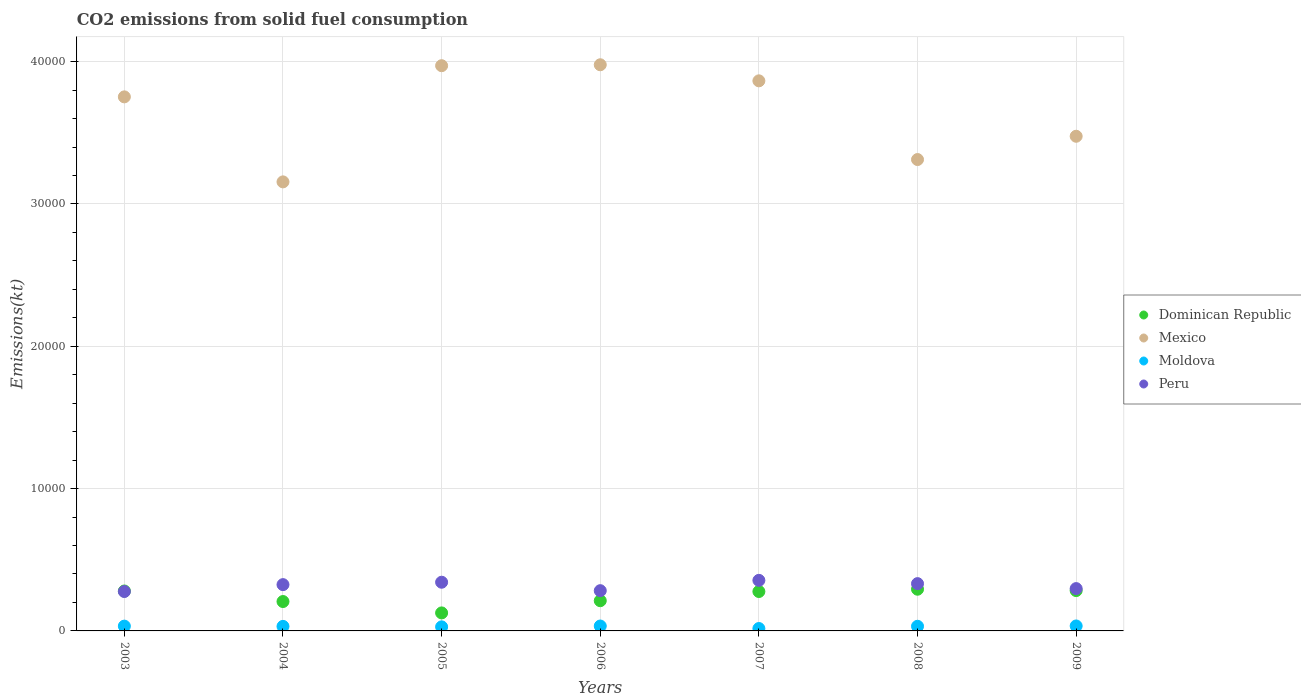What is the amount of CO2 emitted in Mexico in 2005?
Give a very brief answer. 3.97e+04. Across all years, what is the maximum amount of CO2 emitted in Moldova?
Your answer should be compact. 348.37. Across all years, what is the minimum amount of CO2 emitted in Moldova?
Offer a terse response. 168.68. What is the total amount of CO2 emitted in Peru in the graph?
Your response must be concise. 2.21e+04. What is the difference between the amount of CO2 emitted in Peru in 2003 and that in 2004?
Make the answer very short. -484.04. What is the difference between the amount of CO2 emitted in Dominican Republic in 2006 and the amount of CO2 emitted in Peru in 2009?
Your response must be concise. -850.74. What is the average amount of CO2 emitted in Dominican Republic per year?
Offer a very short reply. 2398.74. In the year 2003, what is the difference between the amount of CO2 emitted in Dominican Republic and amount of CO2 emitted in Moldova?
Make the answer very short. 2467.89. In how many years, is the amount of CO2 emitted in Mexico greater than 38000 kt?
Your answer should be compact. 3. What is the ratio of the amount of CO2 emitted in Peru in 2003 to that in 2007?
Give a very brief answer. 0.78. What is the difference between the highest and the second highest amount of CO2 emitted in Mexico?
Provide a succinct answer. 66.01. What is the difference between the highest and the lowest amount of CO2 emitted in Mexico?
Provide a short and direct response. 8228.75. In how many years, is the amount of CO2 emitted in Moldova greater than the average amount of CO2 emitted in Moldova taken over all years?
Offer a terse response. 5. Is the sum of the amount of CO2 emitted in Dominican Republic in 2007 and 2008 greater than the maximum amount of CO2 emitted in Moldova across all years?
Ensure brevity in your answer.  Yes. Is it the case that in every year, the sum of the amount of CO2 emitted in Moldova and amount of CO2 emitted in Mexico  is greater than the sum of amount of CO2 emitted in Peru and amount of CO2 emitted in Dominican Republic?
Provide a short and direct response. Yes. Is it the case that in every year, the sum of the amount of CO2 emitted in Moldova and amount of CO2 emitted in Dominican Republic  is greater than the amount of CO2 emitted in Peru?
Provide a succinct answer. No. Does the amount of CO2 emitted in Peru monotonically increase over the years?
Make the answer very short. No. Is the amount of CO2 emitted in Peru strictly greater than the amount of CO2 emitted in Dominican Republic over the years?
Make the answer very short. No. How many dotlines are there?
Offer a terse response. 4. How many years are there in the graph?
Your answer should be compact. 7. Are the values on the major ticks of Y-axis written in scientific E-notation?
Give a very brief answer. No. Does the graph contain any zero values?
Provide a succinct answer. No. Does the graph contain grids?
Your answer should be compact. Yes. How many legend labels are there?
Keep it short and to the point. 4. How are the legend labels stacked?
Your response must be concise. Vertical. What is the title of the graph?
Make the answer very short. CO2 emissions from solid fuel consumption. Does "Comoros" appear as one of the legend labels in the graph?
Your answer should be very brief. No. What is the label or title of the Y-axis?
Your answer should be compact. Emissions(kt). What is the Emissions(kt) in Dominican Republic in 2003?
Give a very brief answer. 2805.26. What is the Emissions(kt) of Mexico in 2003?
Give a very brief answer. 3.75e+04. What is the Emissions(kt) of Moldova in 2003?
Offer a terse response. 337.36. What is the Emissions(kt) of Peru in 2003?
Your response must be concise. 2768.59. What is the Emissions(kt) of Dominican Republic in 2004?
Give a very brief answer. 2064.52. What is the Emissions(kt) of Mexico in 2004?
Offer a very short reply. 3.16e+04. What is the Emissions(kt) of Moldova in 2004?
Make the answer very short. 319.03. What is the Emissions(kt) in Peru in 2004?
Offer a terse response. 3252.63. What is the Emissions(kt) in Dominican Republic in 2005?
Your response must be concise. 1265.12. What is the Emissions(kt) of Mexico in 2005?
Provide a succinct answer. 3.97e+04. What is the Emissions(kt) of Moldova in 2005?
Make the answer very short. 286.03. What is the Emissions(kt) of Peru in 2005?
Your response must be concise. 3421.31. What is the Emissions(kt) in Dominican Republic in 2006?
Keep it short and to the point. 2123.19. What is the Emissions(kt) in Mexico in 2006?
Offer a terse response. 3.98e+04. What is the Emissions(kt) in Moldova in 2006?
Ensure brevity in your answer.  344.7. What is the Emissions(kt) of Peru in 2006?
Give a very brief answer. 2827.26. What is the Emissions(kt) in Dominican Republic in 2007?
Make the answer very short. 2768.59. What is the Emissions(kt) of Mexico in 2007?
Give a very brief answer. 3.87e+04. What is the Emissions(kt) in Moldova in 2007?
Make the answer very short. 168.68. What is the Emissions(kt) in Peru in 2007?
Give a very brief answer. 3553.32. What is the Emissions(kt) in Dominican Republic in 2008?
Keep it short and to the point. 2929.93. What is the Emissions(kt) in Mexico in 2008?
Offer a very short reply. 3.31e+04. What is the Emissions(kt) in Moldova in 2008?
Offer a very short reply. 326.36. What is the Emissions(kt) in Peru in 2008?
Offer a very short reply. 3322.3. What is the Emissions(kt) in Dominican Republic in 2009?
Ensure brevity in your answer.  2834.59. What is the Emissions(kt) of Mexico in 2009?
Provide a short and direct response. 3.48e+04. What is the Emissions(kt) in Moldova in 2009?
Provide a short and direct response. 348.37. What is the Emissions(kt) of Peru in 2009?
Provide a succinct answer. 2973.94. Across all years, what is the maximum Emissions(kt) in Dominican Republic?
Keep it short and to the point. 2929.93. Across all years, what is the maximum Emissions(kt) of Mexico?
Make the answer very short. 3.98e+04. Across all years, what is the maximum Emissions(kt) in Moldova?
Make the answer very short. 348.37. Across all years, what is the maximum Emissions(kt) in Peru?
Keep it short and to the point. 3553.32. Across all years, what is the minimum Emissions(kt) in Dominican Republic?
Make the answer very short. 1265.12. Across all years, what is the minimum Emissions(kt) of Mexico?
Make the answer very short. 3.16e+04. Across all years, what is the minimum Emissions(kt) in Moldova?
Your answer should be very brief. 168.68. Across all years, what is the minimum Emissions(kt) of Peru?
Offer a terse response. 2768.59. What is the total Emissions(kt) of Dominican Republic in the graph?
Offer a terse response. 1.68e+04. What is the total Emissions(kt) of Mexico in the graph?
Your answer should be very brief. 2.55e+05. What is the total Emissions(kt) of Moldova in the graph?
Your response must be concise. 2130.53. What is the total Emissions(kt) in Peru in the graph?
Provide a short and direct response. 2.21e+04. What is the difference between the Emissions(kt) of Dominican Republic in 2003 and that in 2004?
Give a very brief answer. 740.73. What is the difference between the Emissions(kt) of Mexico in 2003 and that in 2004?
Provide a short and direct response. 5973.54. What is the difference between the Emissions(kt) of Moldova in 2003 and that in 2004?
Give a very brief answer. 18.34. What is the difference between the Emissions(kt) in Peru in 2003 and that in 2004?
Your response must be concise. -484.04. What is the difference between the Emissions(kt) of Dominican Republic in 2003 and that in 2005?
Provide a succinct answer. 1540.14. What is the difference between the Emissions(kt) in Mexico in 2003 and that in 2005?
Offer a very short reply. -2189.2. What is the difference between the Emissions(kt) of Moldova in 2003 and that in 2005?
Your answer should be compact. 51.34. What is the difference between the Emissions(kt) of Peru in 2003 and that in 2005?
Your response must be concise. -652.73. What is the difference between the Emissions(kt) in Dominican Republic in 2003 and that in 2006?
Ensure brevity in your answer.  682.06. What is the difference between the Emissions(kt) in Mexico in 2003 and that in 2006?
Your answer should be compact. -2255.2. What is the difference between the Emissions(kt) of Moldova in 2003 and that in 2006?
Provide a succinct answer. -7.33. What is the difference between the Emissions(kt) in Peru in 2003 and that in 2006?
Keep it short and to the point. -58.67. What is the difference between the Emissions(kt) in Dominican Republic in 2003 and that in 2007?
Keep it short and to the point. 36.67. What is the difference between the Emissions(kt) in Mexico in 2003 and that in 2007?
Your answer should be compact. -1125.77. What is the difference between the Emissions(kt) of Moldova in 2003 and that in 2007?
Keep it short and to the point. 168.68. What is the difference between the Emissions(kt) of Peru in 2003 and that in 2007?
Offer a terse response. -784.74. What is the difference between the Emissions(kt) in Dominican Republic in 2003 and that in 2008?
Offer a terse response. -124.68. What is the difference between the Emissions(kt) in Mexico in 2003 and that in 2008?
Offer a terse response. 4404.07. What is the difference between the Emissions(kt) of Moldova in 2003 and that in 2008?
Keep it short and to the point. 11. What is the difference between the Emissions(kt) of Peru in 2003 and that in 2008?
Provide a short and direct response. -553.72. What is the difference between the Emissions(kt) of Dominican Republic in 2003 and that in 2009?
Your answer should be compact. -29.34. What is the difference between the Emissions(kt) of Mexico in 2003 and that in 2009?
Ensure brevity in your answer.  2768.59. What is the difference between the Emissions(kt) of Moldova in 2003 and that in 2009?
Provide a short and direct response. -11. What is the difference between the Emissions(kt) of Peru in 2003 and that in 2009?
Keep it short and to the point. -205.35. What is the difference between the Emissions(kt) in Dominican Republic in 2004 and that in 2005?
Your answer should be compact. 799.41. What is the difference between the Emissions(kt) of Mexico in 2004 and that in 2005?
Provide a short and direct response. -8162.74. What is the difference between the Emissions(kt) in Moldova in 2004 and that in 2005?
Your answer should be compact. 33. What is the difference between the Emissions(kt) of Peru in 2004 and that in 2005?
Your answer should be compact. -168.68. What is the difference between the Emissions(kt) in Dominican Republic in 2004 and that in 2006?
Offer a very short reply. -58.67. What is the difference between the Emissions(kt) of Mexico in 2004 and that in 2006?
Provide a succinct answer. -8228.75. What is the difference between the Emissions(kt) in Moldova in 2004 and that in 2006?
Ensure brevity in your answer.  -25.67. What is the difference between the Emissions(kt) in Peru in 2004 and that in 2006?
Make the answer very short. 425.37. What is the difference between the Emissions(kt) of Dominican Republic in 2004 and that in 2007?
Make the answer very short. -704.06. What is the difference between the Emissions(kt) of Mexico in 2004 and that in 2007?
Ensure brevity in your answer.  -7099.31. What is the difference between the Emissions(kt) of Moldova in 2004 and that in 2007?
Your answer should be compact. 150.35. What is the difference between the Emissions(kt) of Peru in 2004 and that in 2007?
Provide a succinct answer. -300.69. What is the difference between the Emissions(kt) of Dominican Republic in 2004 and that in 2008?
Your answer should be compact. -865.41. What is the difference between the Emissions(kt) in Mexico in 2004 and that in 2008?
Your answer should be compact. -1569.48. What is the difference between the Emissions(kt) of Moldova in 2004 and that in 2008?
Ensure brevity in your answer.  -7.33. What is the difference between the Emissions(kt) of Peru in 2004 and that in 2008?
Keep it short and to the point. -69.67. What is the difference between the Emissions(kt) in Dominican Republic in 2004 and that in 2009?
Make the answer very short. -770.07. What is the difference between the Emissions(kt) in Mexico in 2004 and that in 2009?
Your answer should be very brief. -3204.96. What is the difference between the Emissions(kt) of Moldova in 2004 and that in 2009?
Provide a succinct answer. -29.34. What is the difference between the Emissions(kt) of Peru in 2004 and that in 2009?
Your response must be concise. 278.69. What is the difference between the Emissions(kt) of Dominican Republic in 2005 and that in 2006?
Provide a succinct answer. -858.08. What is the difference between the Emissions(kt) of Mexico in 2005 and that in 2006?
Keep it short and to the point. -66.01. What is the difference between the Emissions(kt) of Moldova in 2005 and that in 2006?
Your answer should be very brief. -58.67. What is the difference between the Emissions(kt) in Peru in 2005 and that in 2006?
Your answer should be very brief. 594.05. What is the difference between the Emissions(kt) of Dominican Republic in 2005 and that in 2007?
Make the answer very short. -1503.47. What is the difference between the Emissions(kt) in Mexico in 2005 and that in 2007?
Give a very brief answer. 1063.43. What is the difference between the Emissions(kt) in Moldova in 2005 and that in 2007?
Your answer should be compact. 117.34. What is the difference between the Emissions(kt) of Peru in 2005 and that in 2007?
Your response must be concise. -132.01. What is the difference between the Emissions(kt) in Dominican Republic in 2005 and that in 2008?
Ensure brevity in your answer.  -1664.82. What is the difference between the Emissions(kt) of Mexico in 2005 and that in 2008?
Provide a succinct answer. 6593.27. What is the difference between the Emissions(kt) of Moldova in 2005 and that in 2008?
Provide a short and direct response. -40.34. What is the difference between the Emissions(kt) in Peru in 2005 and that in 2008?
Offer a terse response. 99.01. What is the difference between the Emissions(kt) of Dominican Republic in 2005 and that in 2009?
Offer a terse response. -1569.48. What is the difference between the Emissions(kt) in Mexico in 2005 and that in 2009?
Keep it short and to the point. 4957.78. What is the difference between the Emissions(kt) of Moldova in 2005 and that in 2009?
Give a very brief answer. -62.34. What is the difference between the Emissions(kt) of Peru in 2005 and that in 2009?
Ensure brevity in your answer.  447.37. What is the difference between the Emissions(kt) of Dominican Republic in 2006 and that in 2007?
Provide a succinct answer. -645.39. What is the difference between the Emissions(kt) in Mexico in 2006 and that in 2007?
Give a very brief answer. 1129.44. What is the difference between the Emissions(kt) in Moldova in 2006 and that in 2007?
Ensure brevity in your answer.  176.02. What is the difference between the Emissions(kt) of Peru in 2006 and that in 2007?
Make the answer very short. -726.07. What is the difference between the Emissions(kt) in Dominican Republic in 2006 and that in 2008?
Make the answer very short. -806.74. What is the difference between the Emissions(kt) of Mexico in 2006 and that in 2008?
Your answer should be compact. 6659.27. What is the difference between the Emissions(kt) in Moldova in 2006 and that in 2008?
Give a very brief answer. 18.34. What is the difference between the Emissions(kt) in Peru in 2006 and that in 2008?
Provide a succinct answer. -495.05. What is the difference between the Emissions(kt) in Dominican Republic in 2006 and that in 2009?
Provide a succinct answer. -711.4. What is the difference between the Emissions(kt) in Mexico in 2006 and that in 2009?
Make the answer very short. 5023.79. What is the difference between the Emissions(kt) of Moldova in 2006 and that in 2009?
Give a very brief answer. -3.67. What is the difference between the Emissions(kt) in Peru in 2006 and that in 2009?
Offer a terse response. -146.68. What is the difference between the Emissions(kt) of Dominican Republic in 2007 and that in 2008?
Offer a terse response. -161.35. What is the difference between the Emissions(kt) of Mexico in 2007 and that in 2008?
Keep it short and to the point. 5529.84. What is the difference between the Emissions(kt) in Moldova in 2007 and that in 2008?
Keep it short and to the point. -157.68. What is the difference between the Emissions(kt) of Peru in 2007 and that in 2008?
Ensure brevity in your answer.  231.02. What is the difference between the Emissions(kt) of Dominican Republic in 2007 and that in 2009?
Provide a succinct answer. -66.01. What is the difference between the Emissions(kt) in Mexico in 2007 and that in 2009?
Keep it short and to the point. 3894.35. What is the difference between the Emissions(kt) of Moldova in 2007 and that in 2009?
Give a very brief answer. -179.68. What is the difference between the Emissions(kt) of Peru in 2007 and that in 2009?
Ensure brevity in your answer.  579.39. What is the difference between the Emissions(kt) of Dominican Republic in 2008 and that in 2009?
Offer a very short reply. 95.34. What is the difference between the Emissions(kt) of Mexico in 2008 and that in 2009?
Make the answer very short. -1635.48. What is the difference between the Emissions(kt) of Moldova in 2008 and that in 2009?
Your answer should be compact. -22. What is the difference between the Emissions(kt) in Peru in 2008 and that in 2009?
Provide a succinct answer. 348.37. What is the difference between the Emissions(kt) in Dominican Republic in 2003 and the Emissions(kt) in Mexico in 2004?
Make the answer very short. -2.87e+04. What is the difference between the Emissions(kt) in Dominican Republic in 2003 and the Emissions(kt) in Moldova in 2004?
Make the answer very short. 2486.23. What is the difference between the Emissions(kt) in Dominican Republic in 2003 and the Emissions(kt) in Peru in 2004?
Your response must be concise. -447.37. What is the difference between the Emissions(kt) of Mexico in 2003 and the Emissions(kt) of Moldova in 2004?
Give a very brief answer. 3.72e+04. What is the difference between the Emissions(kt) of Mexico in 2003 and the Emissions(kt) of Peru in 2004?
Give a very brief answer. 3.43e+04. What is the difference between the Emissions(kt) in Moldova in 2003 and the Emissions(kt) in Peru in 2004?
Keep it short and to the point. -2915.26. What is the difference between the Emissions(kt) in Dominican Republic in 2003 and the Emissions(kt) in Mexico in 2005?
Provide a succinct answer. -3.69e+04. What is the difference between the Emissions(kt) of Dominican Republic in 2003 and the Emissions(kt) of Moldova in 2005?
Give a very brief answer. 2519.23. What is the difference between the Emissions(kt) of Dominican Republic in 2003 and the Emissions(kt) of Peru in 2005?
Your answer should be compact. -616.06. What is the difference between the Emissions(kt) in Mexico in 2003 and the Emissions(kt) in Moldova in 2005?
Provide a succinct answer. 3.72e+04. What is the difference between the Emissions(kt) of Mexico in 2003 and the Emissions(kt) of Peru in 2005?
Offer a terse response. 3.41e+04. What is the difference between the Emissions(kt) in Moldova in 2003 and the Emissions(kt) in Peru in 2005?
Make the answer very short. -3083.95. What is the difference between the Emissions(kt) in Dominican Republic in 2003 and the Emissions(kt) in Mexico in 2006?
Provide a short and direct response. -3.70e+04. What is the difference between the Emissions(kt) of Dominican Republic in 2003 and the Emissions(kt) of Moldova in 2006?
Provide a short and direct response. 2460.56. What is the difference between the Emissions(kt) of Dominican Republic in 2003 and the Emissions(kt) of Peru in 2006?
Your answer should be compact. -22. What is the difference between the Emissions(kt) of Mexico in 2003 and the Emissions(kt) of Moldova in 2006?
Ensure brevity in your answer.  3.72e+04. What is the difference between the Emissions(kt) of Mexico in 2003 and the Emissions(kt) of Peru in 2006?
Offer a terse response. 3.47e+04. What is the difference between the Emissions(kt) of Moldova in 2003 and the Emissions(kt) of Peru in 2006?
Your answer should be compact. -2489.89. What is the difference between the Emissions(kt) in Dominican Republic in 2003 and the Emissions(kt) in Mexico in 2007?
Offer a very short reply. -3.58e+04. What is the difference between the Emissions(kt) in Dominican Republic in 2003 and the Emissions(kt) in Moldova in 2007?
Offer a terse response. 2636.57. What is the difference between the Emissions(kt) of Dominican Republic in 2003 and the Emissions(kt) of Peru in 2007?
Provide a short and direct response. -748.07. What is the difference between the Emissions(kt) of Mexico in 2003 and the Emissions(kt) of Moldova in 2007?
Your answer should be very brief. 3.74e+04. What is the difference between the Emissions(kt) in Mexico in 2003 and the Emissions(kt) in Peru in 2007?
Give a very brief answer. 3.40e+04. What is the difference between the Emissions(kt) in Moldova in 2003 and the Emissions(kt) in Peru in 2007?
Give a very brief answer. -3215.96. What is the difference between the Emissions(kt) in Dominican Republic in 2003 and the Emissions(kt) in Mexico in 2008?
Offer a very short reply. -3.03e+04. What is the difference between the Emissions(kt) in Dominican Republic in 2003 and the Emissions(kt) in Moldova in 2008?
Offer a terse response. 2478.89. What is the difference between the Emissions(kt) of Dominican Republic in 2003 and the Emissions(kt) of Peru in 2008?
Your response must be concise. -517.05. What is the difference between the Emissions(kt) of Mexico in 2003 and the Emissions(kt) of Moldova in 2008?
Offer a terse response. 3.72e+04. What is the difference between the Emissions(kt) in Mexico in 2003 and the Emissions(kt) in Peru in 2008?
Your answer should be compact. 3.42e+04. What is the difference between the Emissions(kt) of Moldova in 2003 and the Emissions(kt) of Peru in 2008?
Provide a succinct answer. -2984.94. What is the difference between the Emissions(kt) in Dominican Republic in 2003 and the Emissions(kt) in Mexico in 2009?
Provide a succinct answer. -3.20e+04. What is the difference between the Emissions(kt) of Dominican Republic in 2003 and the Emissions(kt) of Moldova in 2009?
Offer a very short reply. 2456.89. What is the difference between the Emissions(kt) in Dominican Republic in 2003 and the Emissions(kt) in Peru in 2009?
Provide a succinct answer. -168.68. What is the difference between the Emissions(kt) in Mexico in 2003 and the Emissions(kt) in Moldova in 2009?
Keep it short and to the point. 3.72e+04. What is the difference between the Emissions(kt) in Mexico in 2003 and the Emissions(kt) in Peru in 2009?
Keep it short and to the point. 3.46e+04. What is the difference between the Emissions(kt) of Moldova in 2003 and the Emissions(kt) of Peru in 2009?
Offer a very short reply. -2636.57. What is the difference between the Emissions(kt) of Dominican Republic in 2004 and the Emissions(kt) of Mexico in 2005?
Your response must be concise. -3.76e+04. What is the difference between the Emissions(kt) in Dominican Republic in 2004 and the Emissions(kt) in Moldova in 2005?
Make the answer very short. 1778.49. What is the difference between the Emissions(kt) in Dominican Republic in 2004 and the Emissions(kt) in Peru in 2005?
Offer a terse response. -1356.79. What is the difference between the Emissions(kt) in Mexico in 2004 and the Emissions(kt) in Moldova in 2005?
Give a very brief answer. 3.13e+04. What is the difference between the Emissions(kt) of Mexico in 2004 and the Emissions(kt) of Peru in 2005?
Offer a terse response. 2.81e+04. What is the difference between the Emissions(kt) in Moldova in 2004 and the Emissions(kt) in Peru in 2005?
Your response must be concise. -3102.28. What is the difference between the Emissions(kt) in Dominican Republic in 2004 and the Emissions(kt) in Mexico in 2006?
Your response must be concise. -3.77e+04. What is the difference between the Emissions(kt) in Dominican Republic in 2004 and the Emissions(kt) in Moldova in 2006?
Provide a succinct answer. 1719.82. What is the difference between the Emissions(kt) in Dominican Republic in 2004 and the Emissions(kt) in Peru in 2006?
Keep it short and to the point. -762.74. What is the difference between the Emissions(kt) of Mexico in 2004 and the Emissions(kt) of Moldova in 2006?
Provide a succinct answer. 3.12e+04. What is the difference between the Emissions(kt) in Mexico in 2004 and the Emissions(kt) in Peru in 2006?
Your answer should be compact. 2.87e+04. What is the difference between the Emissions(kt) of Moldova in 2004 and the Emissions(kt) of Peru in 2006?
Your answer should be compact. -2508.23. What is the difference between the Emissions(kt) in Dominican Republic in 2004 and the Emissions(kt) in Mexico in 2007?
Your answer should be compact. -3.66e+04. What is the difference between the Emissions(kt) of Dominican Republic in 2004 and the Emissions(kt) of Moldova in 2007?
Your answer should be very brief. 1895.84. What is the difference between the Emissions(kt) in Dominican Republic in 2004 and the Emissions(kt) in Peru in 2007?
Provide a succinct answer. -1488.8. What is the difference between the Emissions(kt) of Mexico in 2004 and the Emissions(kt) of Moldova in 2007?
Keep it short and to the point. 3.14e+04. What is the difference between the Emissions(kt) of Mexico in 2004 and the Emissions(kt) of Peru in 2007?
Provide a succinct answer. 2.80e+04. What is the difference between the Emissions(kt) in Moldova in 2004 and the Emissions(kt) in Peru in 2007?
Provide a succinct answer. -3234.29. What is the difference between the Emissions(kt) in Dominican Republic in 2004 and the Emissions(kt) in Mexico in 2008?
Keep it short and to the point. -3.11e+04. What is the difference between the Emissions(kt) of Dominican Republic in 2004 and the Emissions(kt) of Moldova in 2008?
Your answer should be compact. 1738.16. What is the difference between the Emissions(kt) in Dominican Republic in 2004 and the Emissions(kt) in Peru in 2008?
Offer a terse response. -1257.78. What is the difference between the Emissions(kt) of Mexico in 2004 and the Emissions(kt) of Moldova in 2008?
Provide a short and direct response. 3.12e+04. What is the difference between the Emissions(kt) in Mexico in 2004 and the Emissions(kt) in Peru in 2008?
Keep it short and to the point. 2.82e+04. What is the difference between the Emissions(kt) of Moldova in 2004 and the Emissions(kt) of Peru in 2008?
Ensure brevity in your answer.  -3003.27. What is the difference between the Emissions(kt) of Dominican Republic in 2004 and the Emissions(kt) of Mexico in 2009?
Your response must be concise. -3.27e+04. What is the difference between the Emissions(kt) of Dominican Republic in 2004 and the Emissions(kt) of Moldova in 2009?
Offer a terse response. 1716.16. What is the difference between the Emissions(kt) of Dominican Republic in 2004 and the Emissions(kt) of Peru in 2009?
Your response must be concise. -909.42. What is the difference between the Emissions(kt) in Mexico in 2004 and the Emissions(kt) in Moldova in 2009?
Provide a succinct answer. 3.12e+04. What is the difference between the Emissions(kt) of Mexico in 2004 and the Emissions(kt) of Peru in 2009?
Your answer should be very brief. 2.86e+04. What is the difference between the Emissions(kt) in Moldova in 2004 and the Emissions(kt) in Peru in 2009?
Give a very brief answer. -2654.91. What is the difference between the Emissions(kt) of Dominican Republic in 2005 and the Emissions(kt) of Mexico in 2006?
Your response must be concise. -3.85e+04. What is the difference between the Emissions(kt) in Dominican Republic in 2005 and the Emissions(kt) in Moldova in 2006?
Offer a very short reply. 920.42. What is the difference between the Emissions(kt) of Dominican Republic in 2005 and the Emissions(kt) of Peru in 2006?
Your response must be concise. -1562.14. What is the difference between the Emissions(kt) in Mexico in 2005 and the Emissions(kt) in Moldova in 2006?
Give a very brief answer. 3.94e+04. What is the difference between the Emissions(kt) in Mexico in 2005 and the Emissions(kt) in Peru in 2006?
Provide a succinct answer. 3.69e+04. What is the difference between the Emissions(kt) in Moldova in 2005 and the Emissions(kt) in Peru in 2006?
Ensure brevity in your answer.  -2541.23. What is the difference between the Emissions(kt) in Dominican Republic in 2005 and the Emissions(kt) in Mexico in 2007?
Make the answer very short. -3.74e+04. What is the difference between the Emissions(kt) in Dominican Republic in 2005 and the Emissions(kt) in Moldova in 2007?
Make the answer very short. 1096.43. What is the difference between the Emissions(kt) in Dominican Republic in 2005 and the Emissions(kt) in Peru in 2007?
Your response must be concise. -2288.21. What is the difference between the Emissions(kt) in Mexico in 2005 and the Emissions(kt) in Moldova in 2007?
Make the answer very short. 3.95e+04. What is the difference between the Emissions(kt) of Mexico in 2005 and the Emissions(kt) of Peru in 2007?
Your answer should be very brief. 3.62e+04. What is the difference between the Emissions(kt) in Moldova in 2005 and the Emissions(kt) in Peru in 2007?
Provide a succinct answer. -3267.3. What is the difference between the Emissions(kt) of Dominican Republic in 2005 and the Emissions(kt) of Mexico in 2008?
Ensure brevity in your answer.  -3.19e+04. What is the difference between the Emissions(kt) in Dominican Republic in 2005 and the Emissions(kt) in Moldova in 2008?
Offer a terse response. 938.75. What is the difference between the Emissions(kt) in Dominican Republic in 2005 and the Emissions(kt) in Peru in 2008?
Your answer should be compact. -2057.19. What is the difference between the Emissions(kt) of Mexico in 2005 and the Emissions(kt) of Moldova in 2008?
Ensure brevity in your answer.  3.94e+04. What is the difference between the Emissions(kt) in Mexico in 2005 and the Emissions(kt) in Peru in 2008?
Offer a terse response. 3.64e+04. What is the difference between the Emissions(kt) of Moldova in 2005 and the Emissions(kt) of Peru in 2008?
Your response must be concise. -3036.28. What is the difference between the Emissions(kt) in Dominican Republic in 2005 and the Emissions(kt) in Mexico in 2009?
Ensure brevity in your answer.  -3.35e+04. What is the difference between the Emissions(kt) of Dominican Republic in 2005 and the Emissions(kt) of Moldova in 2009?
Keep it short and to the point. 916.75. What is the difference between the Emissions(kt) in Dominican Republic in 2005 and the Emissions(kt) in Peru in 2009?
Provide a succinct answer. -1708.82. What is the difference between the Emissions(kt) in Mexico in 2005 and the Emissions(kt) in Moldova in 2009?
Offer a very short reply. 3.94e+04. What is the difference between the Emissions(kt) in Mexico in 2005 and the Emissions(kt) in Peru in 2009?
Provide a short and direct response. 3.67e+04. What is the difference between the Emissions(kt) of Moldova in 2005 and the Emissions(kt) of Peru in 2009?
Ensure brevity in your answer.  -2687.91. What is the difference between the Emissions(kt) of Dominican Republic in 2006 and the Emissions(kt) of Mexico in 2007?
Provide a short and direct response. -3.65e+04. What is the difference between the Emissions(kt) of Dominican Republic in 2006 and the Emissions(kt) of Moldova in 2007?
Give a very brief answer. 1954.51. What is the difference between the Emissions(kt) in Dominican Republic in 2006 and the Emissions(kt) in Peru in 2007?
Your answer should be very brief. -1430.13. What is the difference between the Emissions(kt) of Mexico in 2006 and the Emissions(kt) of Moldova in 2007?
Make the answer very short. 3.96e+04. What is the difference between the Emissions(kt) of Mexico in 2006 and the Emissions(kt) of Peru in 2007?
Offer a terse response. 3.62e+04. What is the difference between the Emissions(kt) in Moldova in 2006 and the Emissions(kt) in Peru in 2007?
Keep it short and to the point. -3208.62. What is the difference between the Emissions(kt) in Dominican Republic in 2006 and the Emissions(kt) in Mexico in 2008?
Your answer should be compact. -3.10e+04. What is the difference between the Emissions(kt) in Dominican Republic in 2006 and the Emissions(kt) in Moldova in 2008?
Give a very brief answer. 1796.83. What is the difference between the Emissions(kt) of Dominican Republic in 2006 and the Emissions(kt) of Peru in 2008?
Offer a very short reply. -1199.11. What is the difference between the Emissions(kt) of Mexico in 2006 and the Emissions(kt) of Moldova in 2008?
Provide a short and direct response. 3.95e+04. What is the difference between the Emissions(kt) in Mexico in 2006 and the Emissions(kt) in Peru in 2008?
Offer a terse response. 3.65e+04. What is the difference between the Emissions(kt) in Moldova in 2006 and the Emissions(kt) in Peru in 2008?
Offer a terse response. -2977.6. What is the difference between the Emissions(kt) in Dominican Republic in 2006 and the Emissions(kt) in Mexico in 2009?
Your response must be concise. -3.26e+04. What is the difference between the Emissions(kt) of Dominican Republic in 2006 and the Emissions(kt) of Moldova in 2009?
Give a very brief answer. 1774.83. What is the difference between the Emissions(kt) in Dominican Republic in 2006 and the Emissions(kt) in Peru in 2009?
Make the answer very short. -850.74. What is the difference between the Emissions(kt) of Mexico in 2006 and the Emissions(kt) of Moldova in 2009?
Offer a very short reply. 3.94e+04. What is the difference between the Emissions(kt) of Mexico in 2006 and the Emissions(kt) of Peru in 2009?
Offer a terse response. 3.68e+04. What is the difference between the Emissions(kt) of Moldova in 2006 and the Emissions(kt) of Peru in 2009?
Give a very brief answer. -2629.24. What is the difference between the Emissions(kt) in Dominican Republic in 2007 and the Emissions(kt) in Mexico in 2008?
Your response must be concise. -3.04e+04. What is the difference between the Emissions(kt) in Dominican Republic in 2007 and the Emissions(kt) in Moldova in 2008?
Give a very brief answer. 2442.22. What is the difference between the Emissions(kt) in Dominican Republic in 2007 and the Emissions(kt) in Peru in 2008?
Offer a terse response. -553.72. What is the difference between the Emissions(kt) in Mexico in 2007 and the Emissions(kt) in Moldova in 2008?
Provide a succinct answer. 3.83e+04. What is the difference between the Emissions(kt) of Mexico in 2007 and the Emissions(kt) of Peru in 2008?
Provide a short and direct response. 3.53e+04. What is the difference between the Emissions(kt) in Moldova in 2007 and the Emissions(kt) in Peru in 2008?
Give a very brief answer. -3153.62. What is the difference between the Emissions(kt) of Dominican Republic in 2007 and the Emissions(kt) of Mexico in 2009?
Make the answer very short. -3.20e+04. What is the difference between the Emissions(kt) in Dominican Republic in 2007 and the Emissions(kt) in Moldova in 2009?
Your answer should be very brief. 2420.22. What is the difference between the Emissions(kt) in Dominican Republic in 2007 and the Emissions(kt) in Peru in 2009?
Ensure brevity in your answer.  -205.35. What is the difference between the Emissions(kt) in Mexico in 2007 and the Emissions(kt) in Moldova in 2009?
Provide a short and direct response. 3.83e+04. What is the difference between the Emissions(kt) of Mexico in 2007 and the Emissions(kt) of Peru in 2009?
Offer a very short reply. 3.57e+04. What is the difference between the Emissions(kt) in Moldova in 2007 and the Emissions(kt) in Peru in 2009?
Ensure brevity in your answer.  -2805.26. What is the difference between the Emissions(kt) in Dominican Republic in 2008 and the Emissions(kt) in Mexico in 2009?
Offer a very short reply. -3.18e+04. What is the difference between the Emissions(kt) in Dominican Republic in 2008 and the Emissions(kt) in Moldova in 2009?
Ensure brevity in your answer.  2581.57. What is the difference between the Emissions(kt) in Dominican Republic in 2008 and the Emissions(kt) in Peru in 2009?
Offer a terse response. -44. What is the difference between the Emissions(kt) of Mexico in 2008 and the Emissions(kt) of Moldova in 2009?
Provide a short and direct response. 3.28e+04. What is the difference between the Emissions(kt) of Mexico in 2008 and the Emissions(kt) of Peru in 2009?
Your answer should be compact. 3.01e+04. What is the difference between the Emissions(kt) in Moldova in 2008 and the Emissions(kt) in Peru in 2009?
Keep it short and to the point. -2647.57. What is the average Emissions(kt) in Dominican Republic per year?
Provide a short and direct response. 2398.74. What is the average Emissions(kt) in Mexico per year?
Your answer should be very brief. 3.64e+04. What is the average Emissions(kt) in Moldova per year?
Offer a terse response. 304.36. What is the average Emissions(kt) of Peru per year?
Make the answer very short. 3159.91. In the year 2003, what is the difference between the Emissions(kt) in Dominican Republic and Emissions(kt) in Mexico?
Make the answer very short. -3.47e+04. In the year 2003, what is the difference between the Emissions(kt) in Dominican Republic and Emissions(kt) in Moldova?
Ensure brevity in your answer.  2467.89. In the year 2003, what is the difference between the Emissions(kt) in Dominican Republic and Emissions(kt) in Peru?
Provide a short and direct response. 36.67. In the year 2003, what is the difference between the Emissions(kt) in Mexico and Emissions(kt) in Moldova?
Give a very brief answer. 3.72e+04. In the year 2003, what is the difference between the Emissions(kt) of Mexico and Emissions(kt) of Peru?
Provide a short and direct response. 3.48e+04. In the year 2003, what is the difference between the Emissions(kt) of Moldova and Emissions(kt) of Peru?
Provide a short and direct response. -2431.22. In the year 2004, what is the difference between the Emissions(kt) in Dominican Republic and Emissions(kt) in Mexico?
Provide a short and direct response. -2.95e+04. In the year 2004, what is the difference between the Emissions(kt) in Dominican Republic and Emissions(kt) in Moldova?
Offer a terse response. 1745.49. In the year 2004, what is the difference between the Emissions(kt) of Dominican Republic and Emissions(kt) of Peru?
Provide a short and direct response. -1188.11. In the year 2004, what is the difference between the Emissions(kt) of Mexico and Emissions(kt) of Moldova?
Give a very brief answer. 3.12e+04. In the year 2004, what is the difference between the Emissions(kt) in Mexico and Emissions(kt) in Peru?
Provide a succinct answer. 2.83e+04. In the year 2004, what is the difference between the Emissions(kt) in Moldova and Emissions(kt) in Peru?
Give a very brief answer. -2933.6. In the year 2005, what is the difference between the Emissions(kt) of Dominican Republic and Emissions(kt) of Mexico?
Offer a terse response. -3.84e+04. In the year 2005, what is the difference between the Emissions(kt) in Dominican Republic and Emissions(kt) in Moldova?
Offer a very short reply. 979.09. In the year 2005, what is the difference between the Emissions(kt) of Dominican Republic and Emissions(kt) of Peru?
Your response must be concise. -2156.2. In the year 2005, what is the difference between the Emissions(kt) in Mexico and Emissions(kt) in Moldova?
Make the answer very short. 3.94e+04. In the year 2005, what is the difference between the Emissions(kt) in Mexico and Emissions(kt) in Peru?
Provide a succinct answer. 3.63e+04. In the year 2005, what is the difference between the Emissions(kt) of Moldova and Emissions(kt) of Peru?
Give a very brief answer. -3135.28. In the year 2006, what is the difference between the Emissions(kt) in Dominican Republic and Emissions(kt) in Mexico?
Ensure brevity in your answer.  -3.77e+04. In the year 2006, what is the difference between the Emissions(kt) in Dominican Republic and Emissions(kt) in Moldova?
Your answer should be very brief. 1778.49. In the year 2006, what is the difference between the Emissions(kt) of Dominican Republic and Emissions(kt) of Peru?
Your answer should be compact. -704.06. In the year 2006, what is the difference between the Emissions(kt) of Mexico and Emissions(kt) of Moldova?
Give a very brief answer. 3.94e+04. In the year 2006, what is the difference between the Emissions(kt) of Mexico and Emissions(kt) of Peru?
Keep it short and to the point. 3.70e+04. In the year 2006, what is the difference between the Emissions(kt) of Moldova and Emissions(kt) of Peru?
Give a very brief answer. -2482.56. In the year 2007, what is the difference between the Emissions(kt) of Dominican Republic and Emissions(kt) of Mexico?
Your answer should be very brief. -3.59e+04. In the year 2007, what is the difference between the Emissions(kt) of Dominican Republic and Emissions(kt) of Moldova?
Provide a succinct answer. 2599.9. In the year 2007, what is the difference between the Emissions(kt) in Dominican Republic and Emissions(kt) in Peru?
Your answer should be very brief. -784.74. In the year 2007, what is the difference between the Emissions(kt) of Mexico and Emissions(kt) of Moldova?
Make the answer very short. 3.85e+04. In the year 2007, what is the difference between the Emissions(kt) of Mexico and Emissions(kt) of Peru?
Ensure brevity in your answer.  3.51e+04. In the year 2007, what is the difference between the Emissions(kt) of Moldova and Emissions(kt) of Peru?
Make the answer very short. -3384.64. In the year 2008, what is the difference between the Emissions(kt) in Dominican Republic and Emissions(kt) in Mexico?
Keep it short and to the point. -3.02e+04. In the year 2008, what is the difference between the Emissions(kt) of Dominican Republic and Emissions(kt) of Moldova?
Offer a very short reply. 2603.57. In the year 2008, what is the difference between the Emissions(kt) of Dominican Republic and Emissions(kt) of Peru?
Make the answer very short. -392.37. In the year 2008, what is the difference between the Emissions(kt) in Mexico and Emissions(kt) in Moldova?
Your answer should be very brief. 3.28e+04. In the year 2008, what is the difference between the Emissions(kt) in Mexico and Emissions(kt) in Peru?
Keep it short and to the point. 2.98e+04. In the year 2008, what is the difference between the Emissions(kt) in Moldova and Emissions(kt) in Peru?
Your answer should be compact. -2995.94. In the year 2009, what is the difference between the Emissions(kt) of Dominican Republic and Emissions(kt) of Mexico?
Your answer should be compact. -3.19e+04. In the year 2009, what is the difference between the Emissions(kt) of Dominican Republic and Emissions(kt) of Moldova?
Provide a succinct answer. 2486.23. In the year 2009, what is the difference between the Emissions(kt) in Dominican Republic and Emissions(kt) in Peru?
Keep it short and to the point. -139.35. In the year 2009, what is the difference between the Emissions(kt) of Mexico and Emissions(kt) of Moldova?
Ensure brevity in your answer.  3.44e+04. In the year 2009, what is the difference between the Emissions(kt) of Mexico and Emissions(kt) of Peru?
Ensure brevity in your answer.  3.18e+04. In the year 2009, what is the difference between the Emissions(kt) in Moldova and Emissions(kt) in Peru?
Your answer should be very brief. -2625.57. What is the ratio of the Emissions(kt) of Dominican Republic in 2003 to that in 2004?
Make the answer very short. 1.36. What is the ratio of the Emissions(kt) in Mexico in 2003 to that in 2004?
Offer a terse response. 1.19. What is the ratio of the Emissions(kt) in Moldova in 2003 to that in 2004?
Keep it short and to the point. 1.06. What is the ratio of the Emissions(kt) in Peru in 2003 to that in 2004?
Make the answer very short. 0.85. What is the ratio of the Emissions(kt) in Dominican Republic in 2003 to that in 2005?
Your answer should be very brief. 2.22. What is the ratio of the Emissions(kt) of Mexico in 2003 to that in 2005?
Provide a short and direct response. 0.94. What is the ratio of the Emissions(kt) in Moldova in 2003 to that in 2005?
Your response must be concise. 1.18. What is the ratio of the Emissions(kt) in Peru in 2003 to that in 2005?
Your answer should be compact. 0.81. What is the ratio of the Emissions(kt) of Dominican Republic in 2003 to that in 2006?
Give a very brief answer. 1.32. What is the ratio of the Emissions(kt) of Mexico in 2003 to that in 2006?
Keep it short and to the point. 0.94. What is the ratio of the Emissions(kt) in Moldova in 2003 to that in 2006?
Your answer should be compact. 0.98. What is the ratio of the Emissions(kt) of Peru in 2003 to that in 2006?
Make the answer very short. 0.98. What is the ratio of the Emissions(kt) of Dominican Republic in 2003 to that in 2007?
Your response must be concise. 1.01. What is the ratio of the Emissions(kt) in Mexico in 2003 to that in 2007?
Your answer should be very brief. 0.97. What is the ratio of the Emissions(kt) of Peru in 2003 to that in 2007?
Ensure brevity in your answer.  0.78. What is the ratio of the Emissions(kt) in Dominican Republic in 2003 to that in 2008?
Give a very brief answer. 0.96. What is the ratio of the Emissions(kt) of Mexico in 2003 to that in 2008?
Keep it short and to the point. 1.13. What is the ratio of the Emissions(kt) in Moldova in 2003 to that in 2008?
Provide a succinct answer. 1.03. What is the ratio of the Emissions(kt) of Peru in 2003 to that in 2008?
Provide a succinct answer. 0.83. What is the ratio of the Emissions(kt) of Mexico in 2003 to that in 2009?
Provide a succinct answer. 1.08. What is the ratio of the Emissions(kt) in Moldova in 2003 to that in 2009?
Offer a very short reply. 0.97. What is the ratio of the Emissions(kt) of Peru in 2003 to that in 2009?
Your response must be concise. 0.93. What is the ratio of the Emissions(kt) of Dominican Republic in 2004 to that in 2005?
Provide a short and direct response. 1.63. What is the ratio of the Emissions(kt) in Mexico in 2004 to that in 2005?
Offer a terse response. 0.79. What is the ratio of the Emissions(kt) in Moldova in 2004 to that in 2005?
Provide a succinct answer. 1.12. What is the ratio of the Emissions(kt) in Peru in 2004 to that in 2005?
Provide a succinct answer. 0.95. What is the ratio of the Emissions(kt) in Dominican Republic in 2004 to that in 2006?
Provide a short and direct response. 0.97. What is the ratio of the Emissions(kt) in Mexico in 2004 to that in 2006?
Ensure brevity in your answer.  0.79. What is the ratio of the Emissions(kt) in Moldova in 2004 to that in 2006?
Keep it short and to the point. 0.93. What is the ratio of the Emissions(kt) in Peru in 2004 to that in 2006?
Ensure brevity in your answer.  1.15. What is the ratio of the Emissions(kt) in Dominican Republic in 2004 to that in 2007?
Give a very brief answer. 0.75. What is the ratio of the Emissions(kt) of Mexico in 2004 to that in 2007?
Provide a short and direct response. 0.82. What is the ratio of the Emissions(kt) in Moldova in 2004 to that in 2007?
Offer a very short reply. 1.89. What is the ratio of the Emissions(kt) of Peru in 2004 to that in 2007?
Your answer should be compact. 0.92. What is the ratio of the Emissions(kt) in Dominican Republic in 2004 to that in 2008?
Give a very brief answer. 0.7. What is the ratio of the Emissions(kt) of Mexico in 2004 to that in 2008?
Ensure brevity in your answer.  0.95. What is the ratio of the Emissions(kt) in Moldova in 2004 to that in 2008?
Make the answer very short. 0.98. What is the ratio of the Emissions(kt) in Dominican Republic in 2004 to that in 2009?
Your response must be concise. 0.73. What is the ratio of the Emissions(kt) of Mexico in 2004 to that in 2009?
Your answer should be very brief. 0.91. What is the ratio of the Emissions(kt) of Moldova in 2004 to that in 2009?
Offer a very short reply. 0.92. What is the ratio of the Emissions(kt) of Peru in 2004 to that in 2009?
Your answer should be very brief. 1.09. What is the ratio of the Emissions(kt) of Dominican Republic in 2005 to that in 2006?
Ensure brevity in your answer.  0.6. What is the ratio of the Emissions(kt) in Moldova in 2005 to that in 2006?
Keep it short and to the point. 0.83. What is the ratio of the Emissions(kt) of Peru in 2005 to that in 2006?
Make the answer very short. 1.21. What is the ratio of the Emissions(kt) in Dominican Republic in 2005 to that in 2007?
Offer a terse response. 0.46. What is the ratio of the Emissions(kt) of Mexico in 2005 to that in 2007?
Your answer should be compact. 1.03. What is the ratio of the Emissions(kt) of Moldova in 2005 to that in 2007?
Keep it short and to the point. 1.7. What is the ratio of the Emissions(kt) of Peru in 2005 to that in 2007?
Provide a short and direct response. 0.96. What is the ratio of the Emissions(kt) in Dominican Republic in 2005 to that in 2008?
Ensure brevity in your answer.  0.43. What is the ratio of the Emissions(kt) in Mexico in 2005 to that in 2008?
Offer a terse response. 1.2. What is the ratio of the Emissions(kt) of Moldova in 2005 to that in 2008?
Your answer should be compact. 0.88. What is the ratio of the Emissions(kt) in Peru in 2005 to that in 2008?
Provide a succinct answer. 1.03. What is the ratio of the Emissions(kt) in Dominican Republic in 2005 to that in 2009?
Offer a very short reply. 0.45. What is the ratio of the Emissions(kt) of Mexico in 2005 to that in 2009?
Offer a very short reply. 1.14. What is the ratio of the Emissions(kt) in Moldova in 2005 to that in 2009?
Offer a very short reply. 0.82. What is the ratio of the Emissions(kt) of Peru in 2005 to that in 2009?
Give a very brief answer. 1.15. What is the ratio of the Emissions(kt) in Dominican Republic in 2006 to that in 2007?
Your answer should be compact. 0.77. What is the ratio of the Emissions(kt) in Mexico in 2006 to that in 2007?
Your response must be concise. 1.03. What is the ratio of the Emissions(kt) of Moldova in 2006 to that in 2007?
Keep it short and to the point. 2.04. What is the ratio of the Emissions(kt) in Peru in 2006 to that in 2007?
Keep it short and to the point. 0.8. What is the ratio of the Emissions(kt) of Dominican Republic in 2006 to that in 2008?
Offer a very short reply. 0.72. What is the ratio of the Emissions(kt) in Mexico in 2006 to that in 2008?
Your answer should be compact. 1.2. What is the ratio of the Emissions(kt) of Moldova in 2006 to that in 2008?
Give a very brief answer. 1.06. What is the ratio of the Emissions(kt) of Peru in 2006 to that in 2008?
Offer a terse response. 0.85. What is the ratio of the Emissions(kt) in Dominican Republic in 2006 to that in 2009?
Ensure brevity in your answer.  0.75. What is the ratio of the Emissions(kt) in Mexico in 2006 to that in 2009?
Your answer should be very brief. 1.14. What is the ratio of the Emissions(kt) of Moldova in 2006 to that in 2009?
Provide a short and direct response. 0.99. What is the ratio of the Emissions(kt) in Peru in 2006 to that in 2009?
Ensure brevity in your answer.  0.95. What is the ratio of the Emissions(kt) of Dominican Republic in 2007 to that in 2008?
Provide a succinct answer. 0.94. What is the ratio of the Emissions(kt) of Mexico in 2007 to that in 2008?
Ensure brevity in your answer.  1.17. What is the ratio of the Emissions(kt) of Moldova in 2007 to that in 2008?
Give a very brief answer. 0.52. What is the ratio of the Emissions(kt) of Peru in 2007 to that in 2008?
Your answer should be compact. 1.07. What is the ratio of the Emissions(kt) in Dominican Republic in 2007 to that in 2009?
Offer a very short reply. 0.98. What is the ratio of the Emissions(kt) of Mexico in 2007 to that in 2009?
Provide a succinct answer. 1.11. What is the ratio of the Emissions(kt) in Moldova in 2007 to that in 2009?
Offer a terse response. 0.48. What is the ratio of the Emissions(kt) of Peru in 2007 to that in 2009?
Make the answer very short. 1.19. What is the ratio of the Emissions(kt) in Dominican Republic in 2008 to that in 2009?
Keep it short and to the point. 1.03. What is the ratio of the Emissions(kt) of Mexico in 2008 to that in 2009?
Provide a short and direct response. 0.95. What is the ratio of the Emissions(kt) in Moldova in 2008 to that in 2009?
Your answer should be compact. 0.94. What is the ratio of the Emissions(kt) in Peru in 2008 to that in 2009?
Give a very brief answer. 1.12. What is the difference between the highest and the second highest Emissions(kt) in Dominican Republic?
Provide a succinct answer. 95.34. What is the difference between the highest and the second highest Emissions(kt) of Mexico?
Offer a very short reply. 66.01. What is the difference between the highest and the second highest Emissions(kt) of Moldova?
Make the answer very short. 3.67. What is the difference between the highest and the second highest Emissions(kt) in Peru?
Your answer should be compact. 132.01. What is the difference between the highest and the lowest Emissions(kt) of Dominican Republic?
Give a very brief answer. 1664.82. What is the difference between the highest and the lowest Emissions(kt) of Mexico?
Make the answer very short. 8228.75. What is the difference between the highest and the lowest Emissions(kt) of Moldova?
Your answer should be compact. 179.68. What is the difference between the highest and the lowest Emissions(kt) in Peru?
Your answer should be very brief. 784.74. 